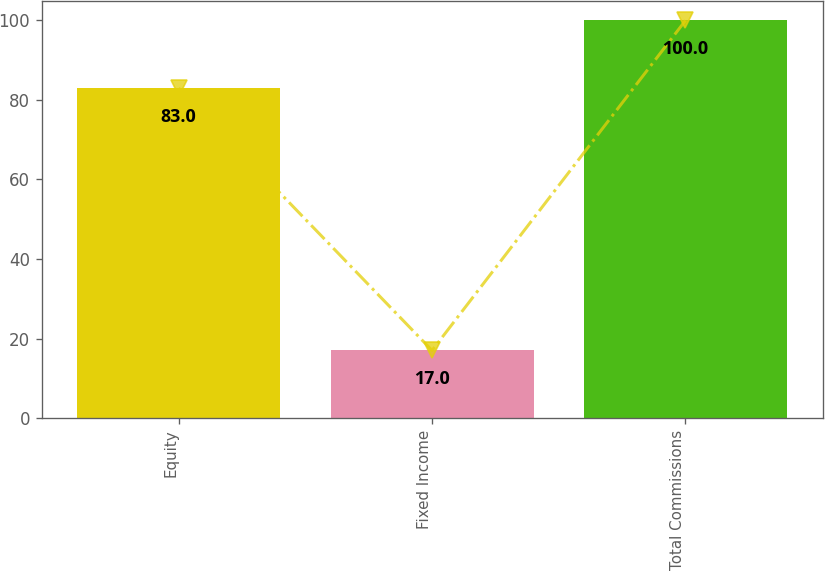Convert chart. <chart><loc_0><loc_0><loc_500><loc_500><bar_chart><fcel>Equity<fcel>Fixed Income<fcel>Total Commissions<nl><fcel>83<fcel>17<fcel>100<nl></chart> 